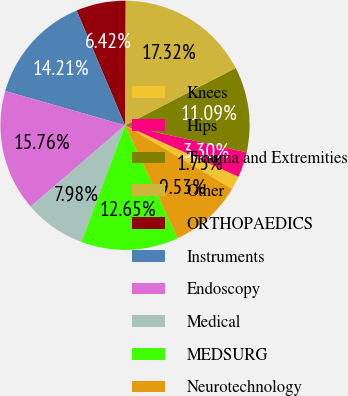Convert chart to OTSL. <chart><loc_0><loc_0><loc_500><loc_500><pie_chart><fcel>Knees<fcel>Hips<fcel>Trauma and Extremities<fcel>Other<fcel>ORTHOPAEDICS<fcel>Instruments<fcel>Endoscopy<fcel>Medical<fcel>MEDSURG<fcel>Neurotechnology<nl><fcel>1.75%<fcel>3.3%<fcel>11.09%<fcel>17.32%<fcel>6.42%<fcel>14.21%<fcel>15.76%<fcel>7.98%<fcel>12.65%<fcel>9.53%<nl></chart> 